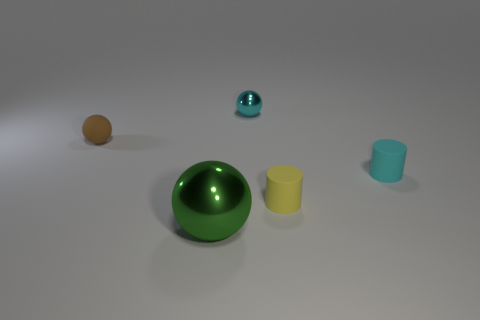Add 5 rubber things. How many objects exist? 10 Subtract all spheres. How many objects are left? 2 Subtract 0 blue cylinders. How many objects are left? 5 Subtract all tiny gray objects. Subtract all large metallic things. How many objects are left? 4 Add 5 small cyan cylinders. How many small cyan cylinders are left? 6 Add 4 small gray rubber things. How many small gray rubber things exist? 4 